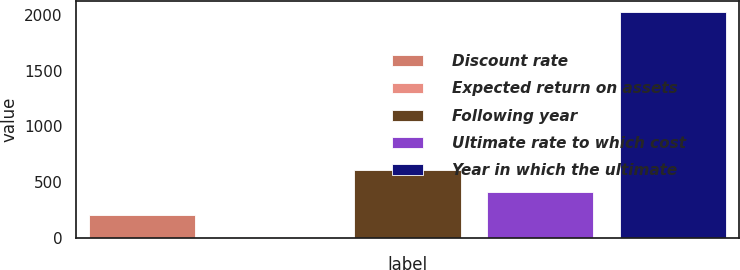Convert chart. <chart><loc_0><loc_0><loc_500><loc_500><bar_chart><fcel>Discount rate<fcel>Expected return on assets<fcel>Following year<fcel>Ultimate rate to which cost<fcel>Year in which the ultimate<nl><fcel>205.4<fcel>3<fcel>610.2<fcel>407.8<fcel>2027<nl></chart> 